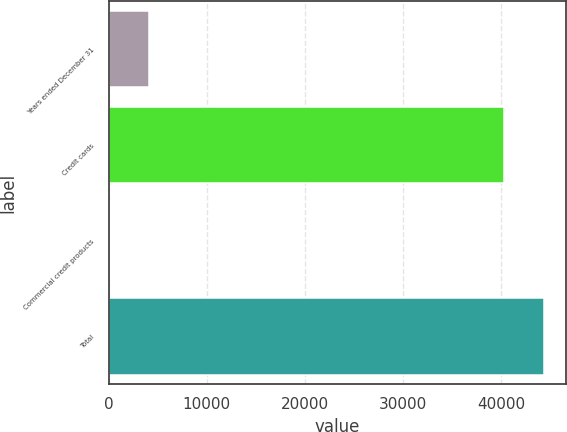<chart> <loc_0><loc_0><loc_500><loc_500><bar_chart><fcel>Years ended December 31<fcel>Credit cards<fcel>Commercial credit products<fcel>Total<nl><fcel>4141.6<fcel>40316<fcel>110<fcel>44347.6<nl></chart> 